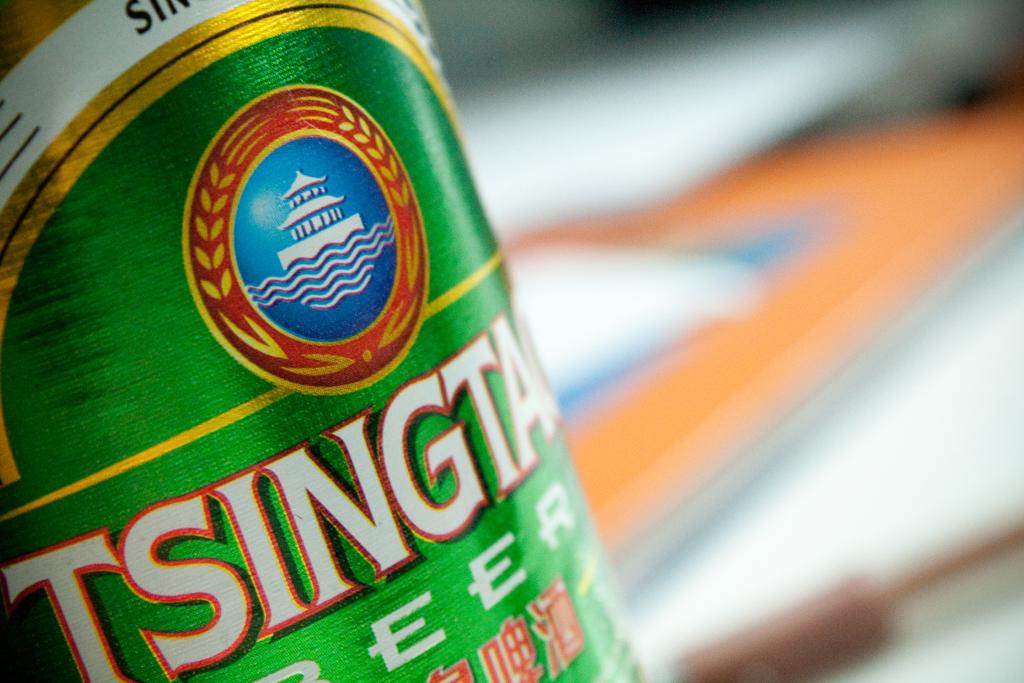<image>
Create a compact narrative representing the image presented. a close up of Tsing Tao Beer with a blurry background 